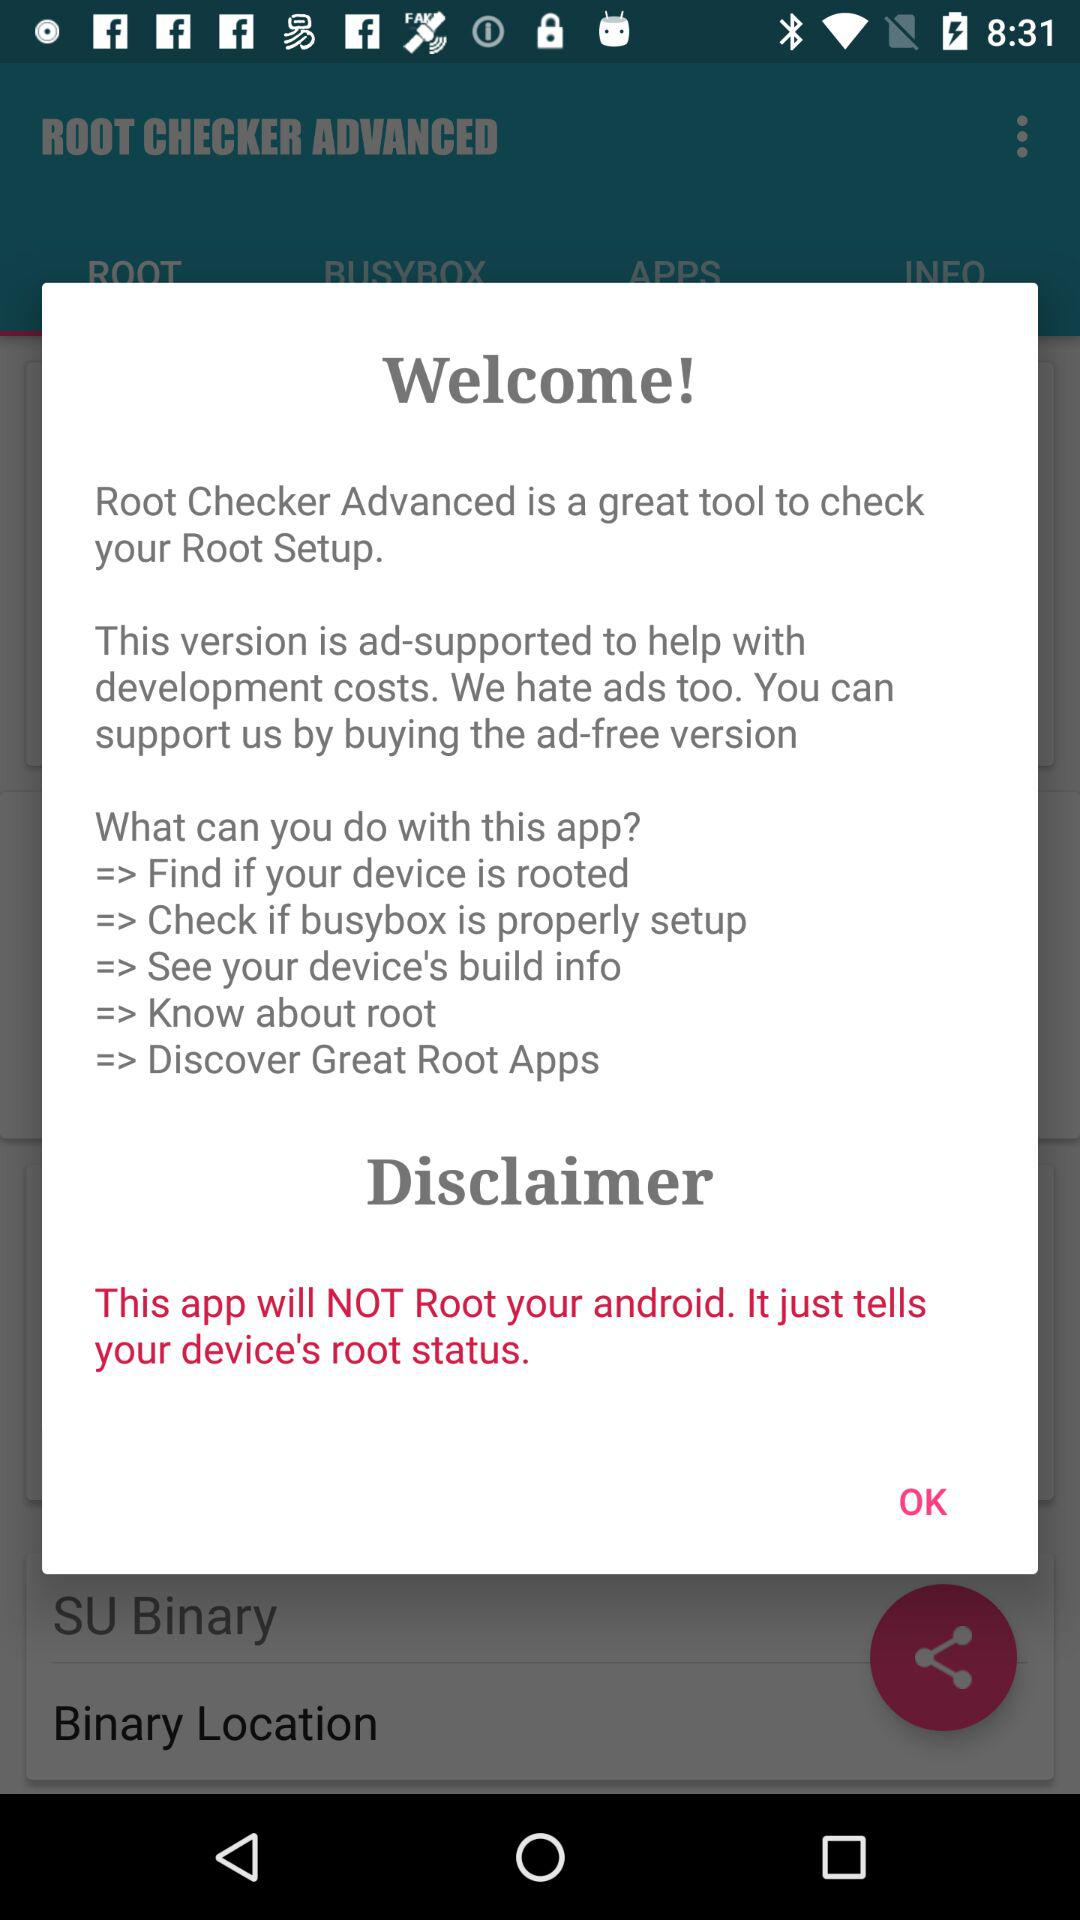How many features does the app support?
Answer the question using a single word or phrase. 5 